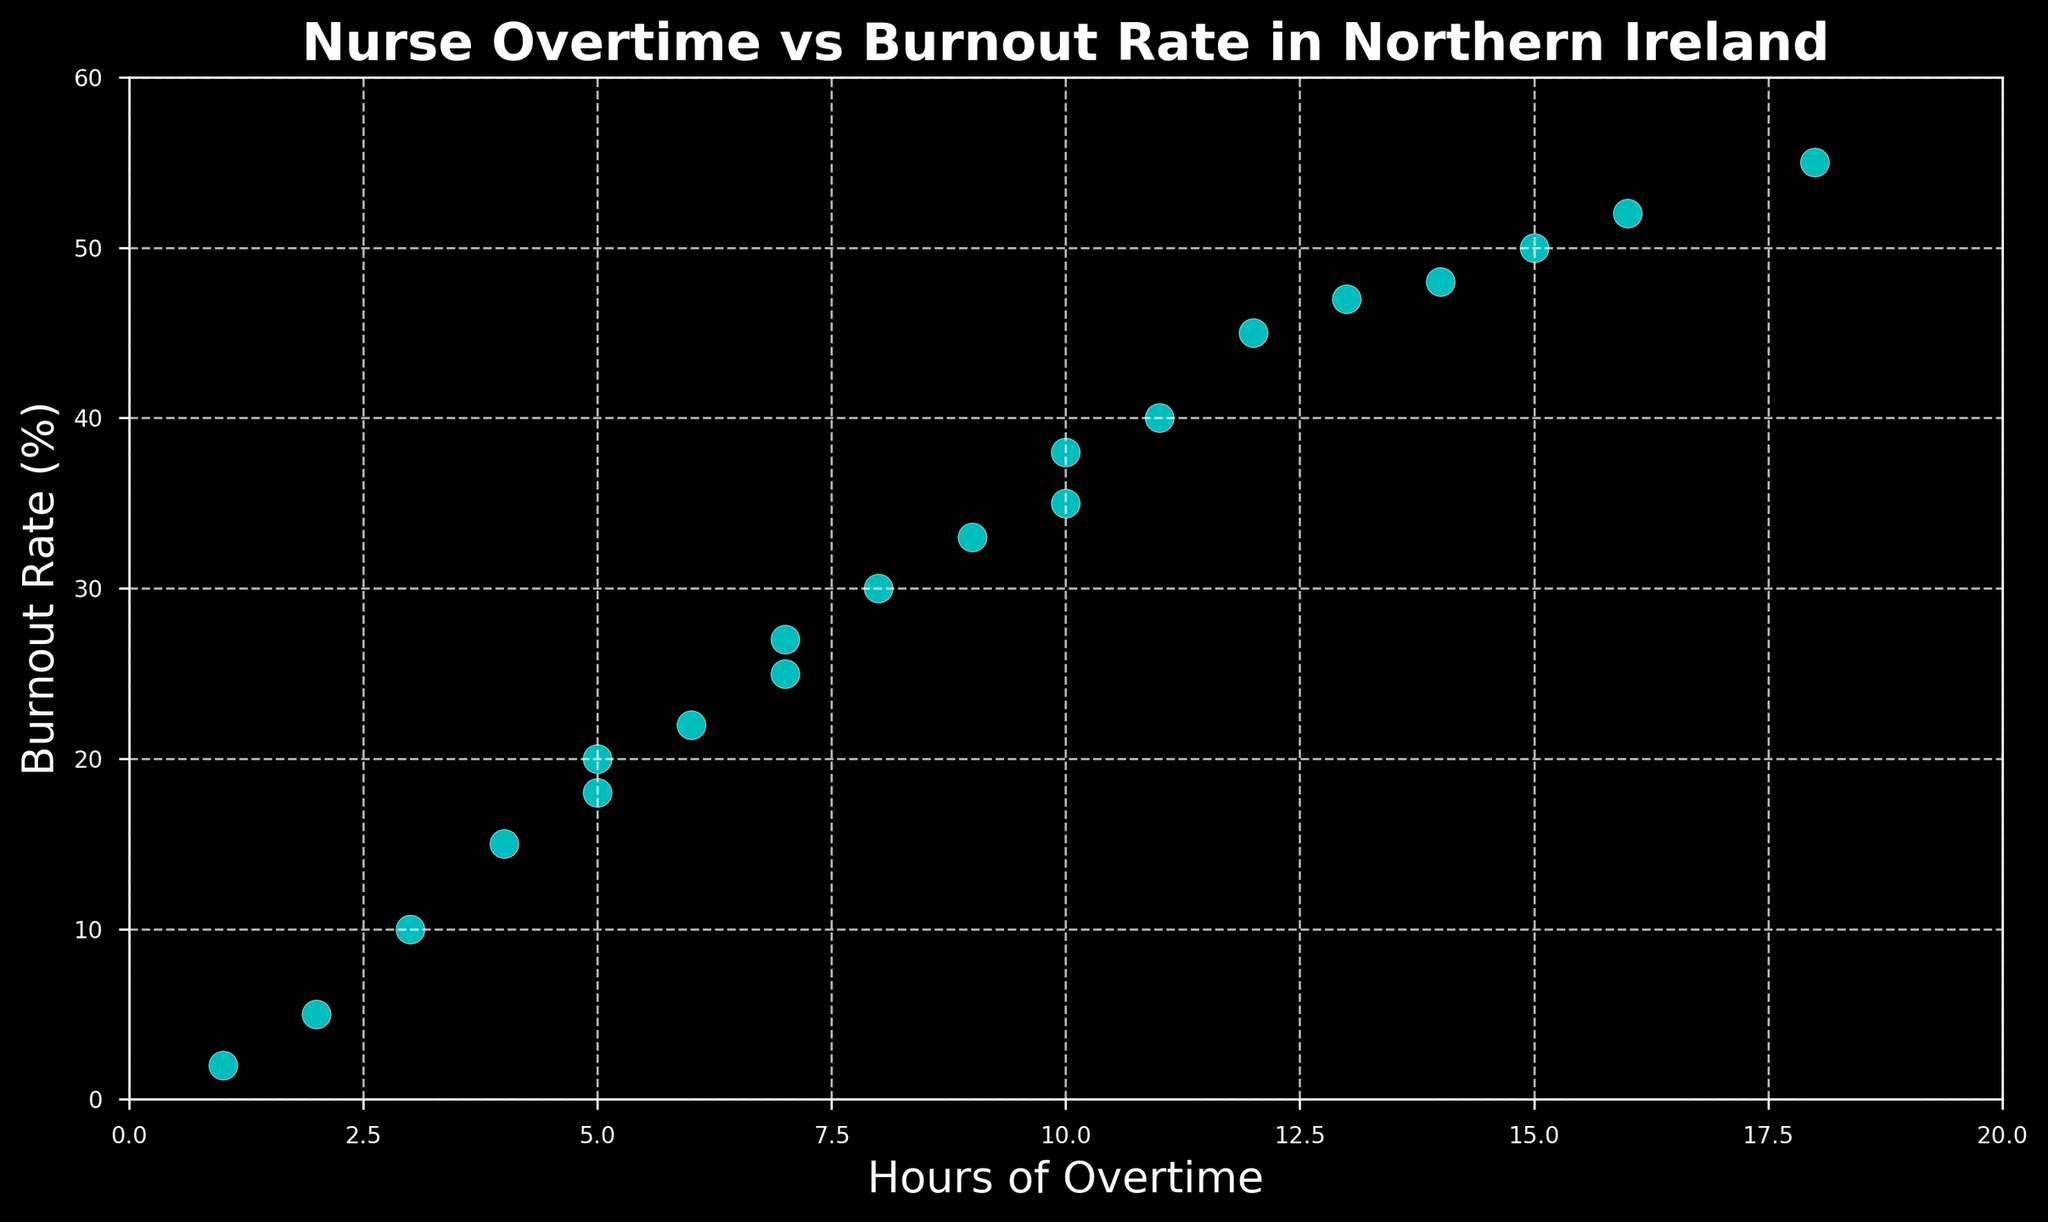What's the average burnout rate when the hours of overtime are greater than 10? First, identify the data points where the hours of overtime are greater than 10: (12, 45), (15, 50), (11, 40), (14, 48), (13, 47), (18, 55), and (16, 52). Sum the burnout rates: 45 + 50 + 40 + 48 + 47 + 55 + 52 = 337. There are 7 data points, so the average burnout rate is 337 / 7 = 48.14.
Answer: 48.14 Which point has the highest burnout rate and how many hours of overtime does it correspond to? The highest burnout rate in the figure is 55%, which corresponds to 18 hours of overtime.
Answer: 18 hours What is the difference in burnout rates between the highest and the lowest overtime hours in the dataset? The highest number of hours of overtime is 18 (with a burnout rate of 55%), and the lowest is 1 (with a burnout rate of 2%). The difference in burnout rates is 55% - 2% = 53%.
Answer: 53% Are there any data points where nurses with the same hours of overtime have different burnout rates? Look for duplicate values in the hours of overtime and compare the burnout rates. For 10 hours of overtime, the burnout rates are 35% and 38%. For 7 hours, the burnout rates are 25% and 27%.
Answer: Yes What is the range of burnout rates for nurses with at least 5 hours of overtime? Identify the data points with at least 5 hours of overtime: (5, 20), (8, 30), (12, 45), (15, 50), (10, 35), (7, 25), (11, 40), (9, 33), (14, 48), (6, 22), (13, 47), (7, 27), (18, 55), and (16, 52). The lowest burnout rate is 20% and the highest is 55%, so the range is 55% - 20% = 35%.
Answer: 35% Is there a positive correlation between hours of overtime and burnout rates? Observe the scatter plot; as the hours of overtime increase, the burnout rate also tends to increase. This trend generally indicates a positive correlation between the two variables.
Answer: Yes 